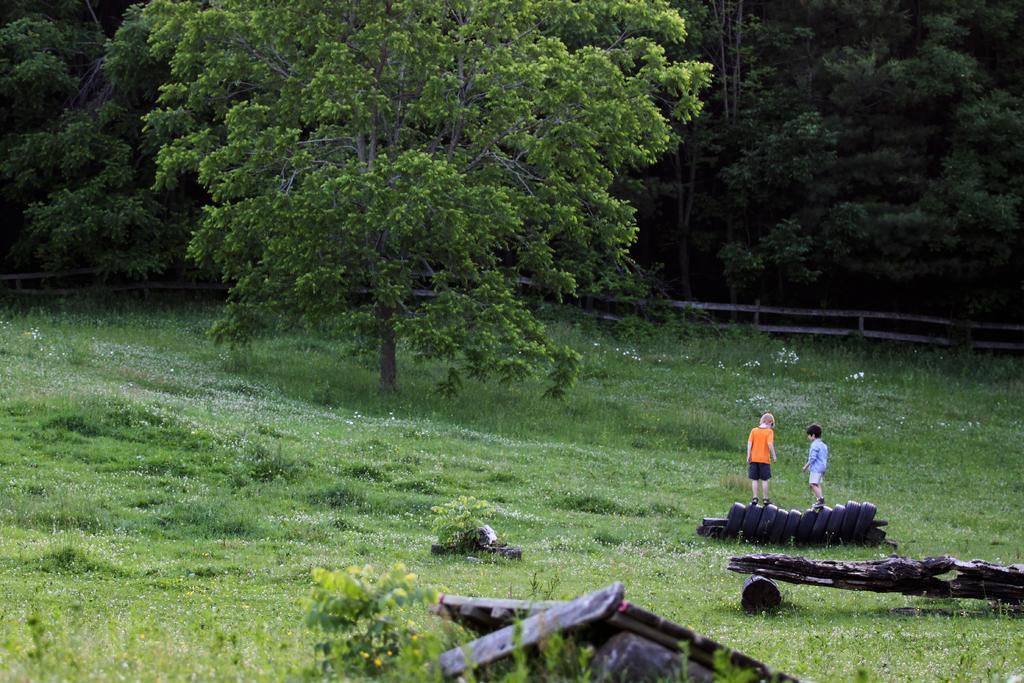Please provide a concise description of this image. In the image there is a grass surface and there are two boys standing on the tyres and there is a tree on the grass surface, behind the tree there are many trees behind a fencing. 